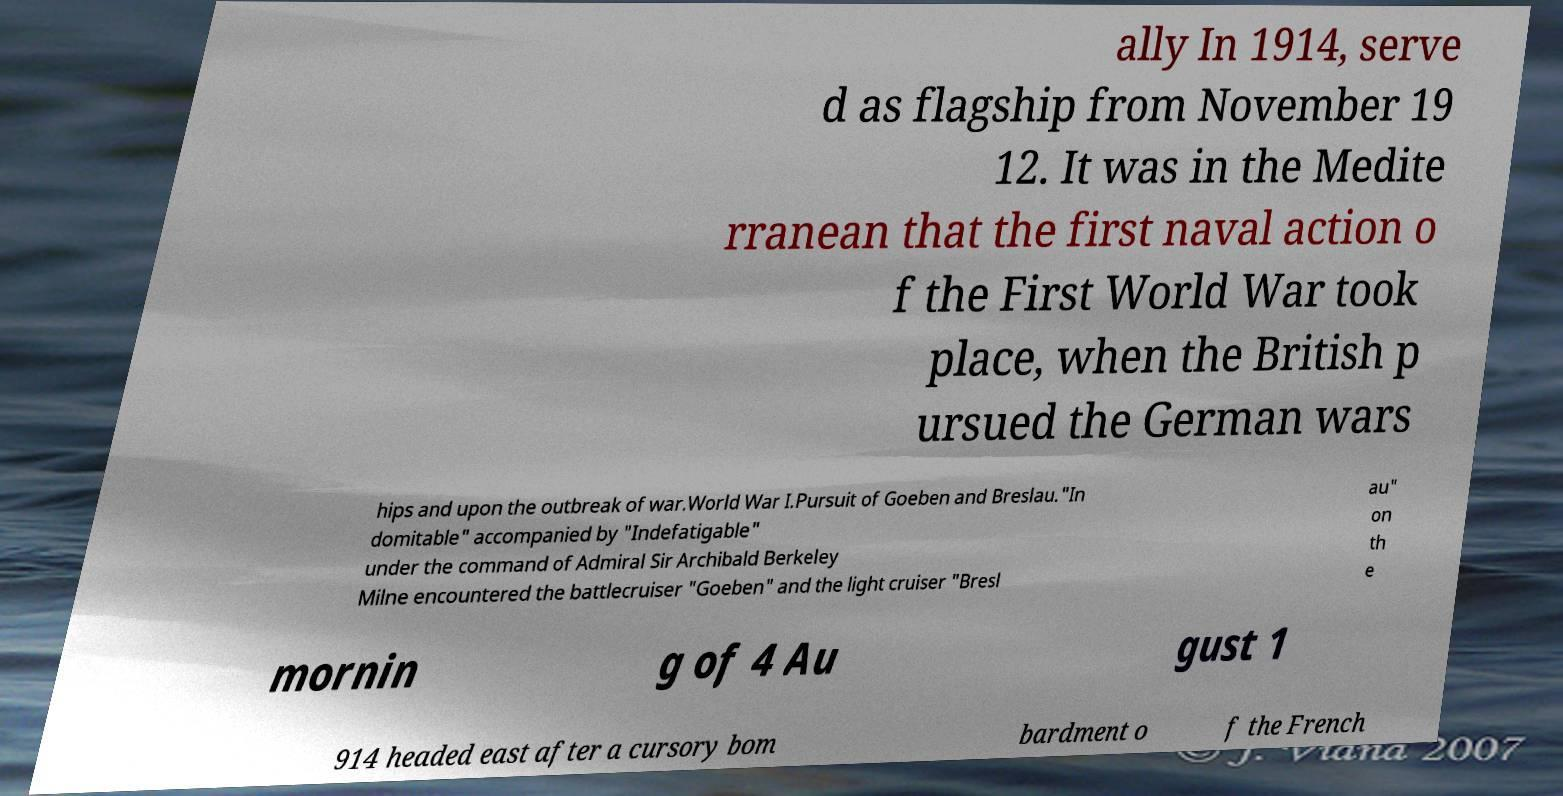Could you extract and type out the text from this image? ally In 1914, serve d as flagship from November 19 12. It was in the Medite rranean that the first naval action o f the First World War took place, when the British p ursued the German wars hips and upon the outbreak of war.World War I.Pursuit of Goeben and Breslau."In domitable" accompanied by "Indefatigable" under the command of Admiral Sir Archibald Berkeley Milne encountered the battlecruiser "Goeben" and the light cruiser "Bresl au" on th e mornin g of 4 Au gust 1 914 headed east after a cursory bom bardment o f the French 